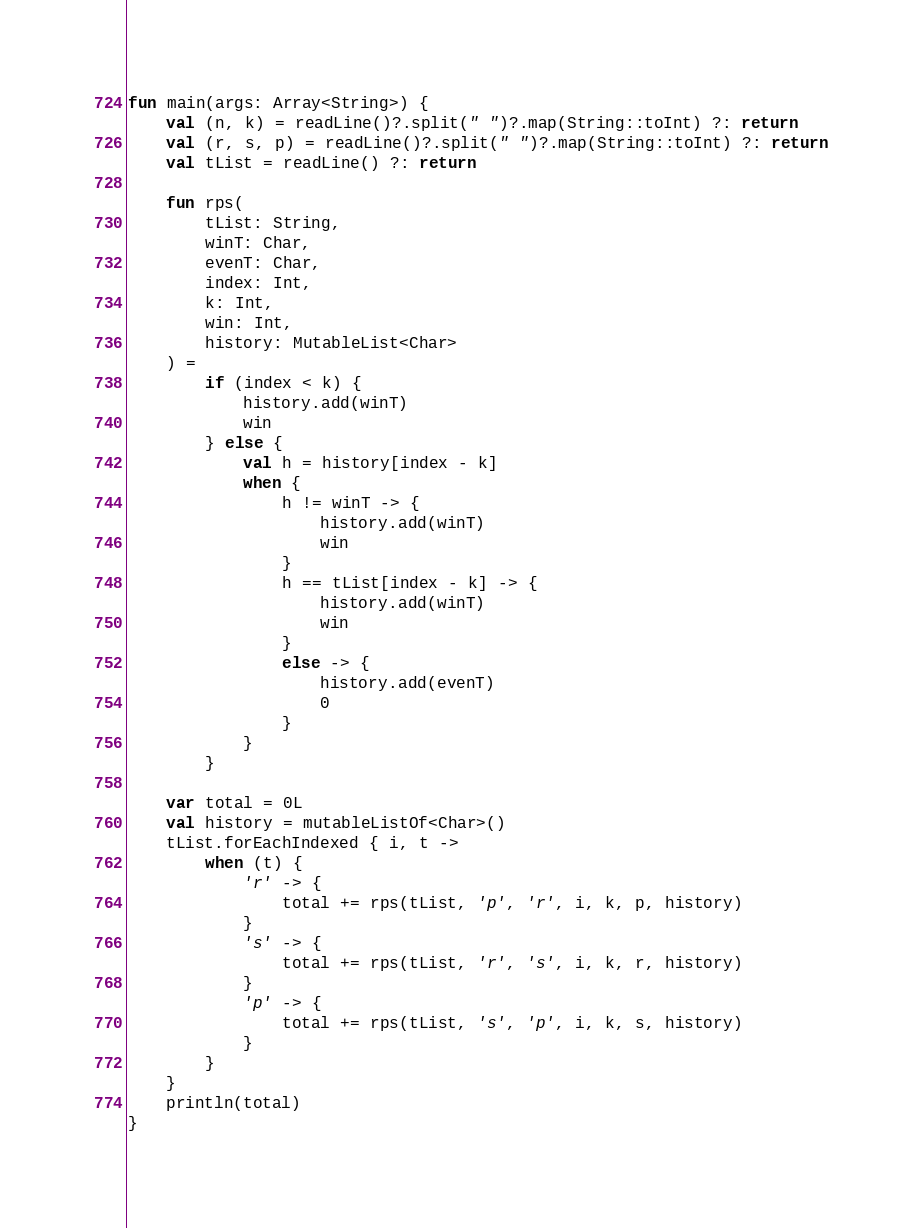Convert code to text. <code><loc_0><loc_0><loc_500><loc_500><_Kotlin_>fun main(args: Array<String>) {
    val (n, k) = readLine()?.split(" ")?.map(String::toInt) ?: return
    val (r, s, p) = readLine()?.split(" ")?.map(String::toInt) ?: return
    val tList = readLine() ?: return

    fun rps(
        tList: String,
        winT: Char,
        evenT: Char,
        index: Int,
        k: Int,
        win: Int,
        history: MutableList<Char>
    ) =
        if (index < k) {
            history.add(winT)
            win
        } else {
            val h = history[index - k]
            when {
                h != winT -> {
                    history.add(winT)
                    win
                }
                h == tList[index - k] -> {
                    history.add(winT)
                    win
                }
                else -> {
                    history.add(evenT)
                    0
                }
            }
        }

    var total = 0L
    val history = mutableListOf<Char>()
    tList.forEachIndexed { i, t ->
        when (t) {
            'r' -> {
                total += rps(tList, 'p', 'r', i, k, p, history)
            }
            's' -> {
                total += rps(tList, 'r', 's', i, k, r, history)
            }
            'p' -> {
                total += rps(tList, 's', 'p', i, k, s, history)
            }
        }
    }
    println(total)
}</code> 